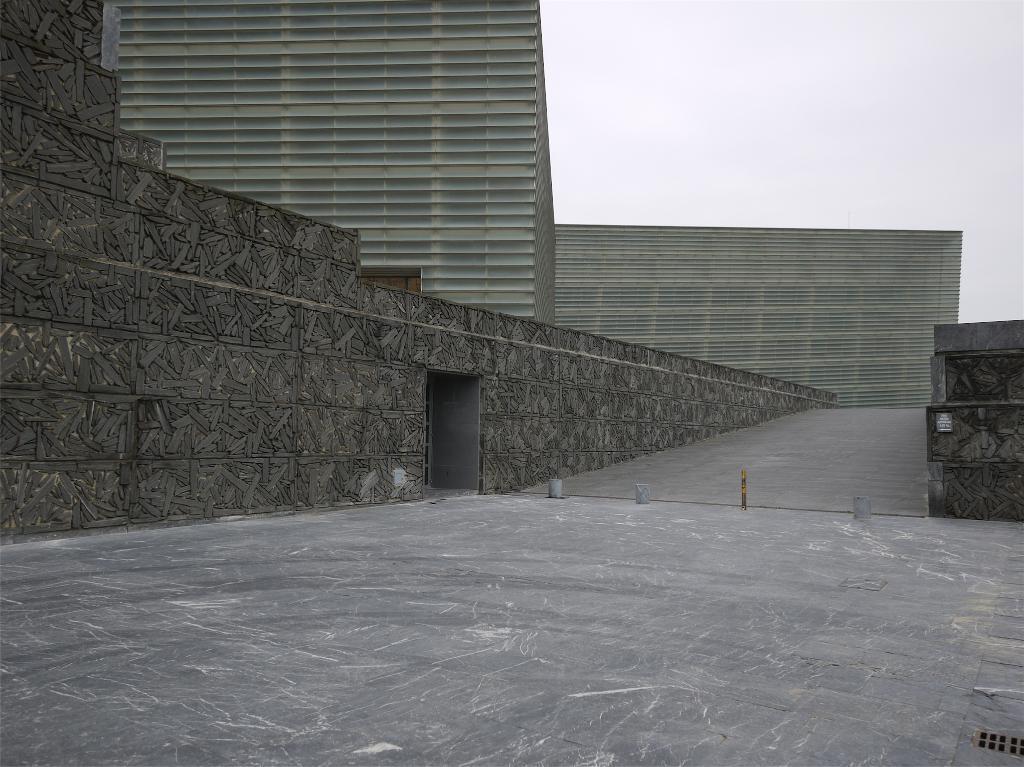Can you describe this image briefly? In this image I can see the road. To the side of the road I can see the wall and the building. In the background I can see the sky. 